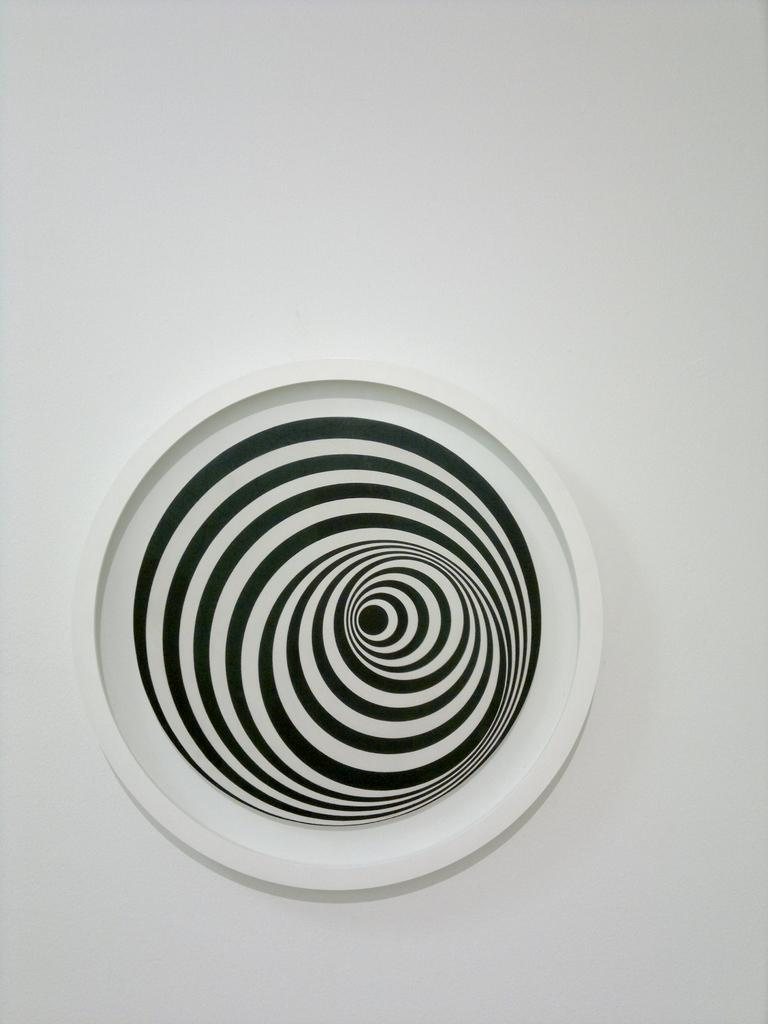What object is present on the white surface in the image? There is a plate in the image. What is the color pattern of the plate? The plate has a white and black color pattern. Where is the plate located in the image? The plate is on a white surface. What month is depicted on the plate in the image? There is no month depicted on the plate in the image; it has a white and black color pattern. 